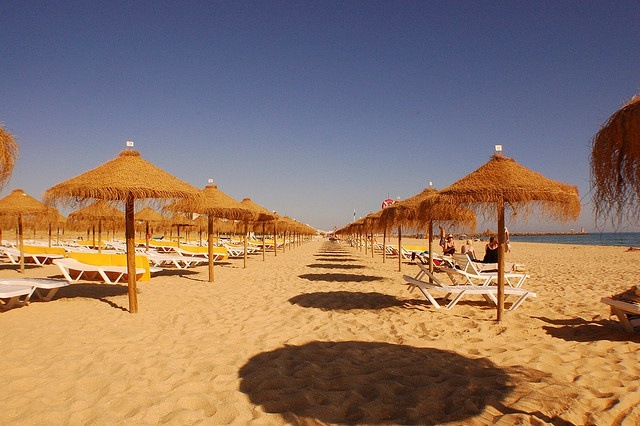Describe the objects in this image and their specific colors. I can see umbrella in darkblue, red, maroon, and gray tones, umbrella in darkblue, orange, and red tones, umbrella in darkblue, brown, maroon, and gray tones, chair in darkblue, tan, and beige tones, and bench in darkblue, tan, maroon, and beige tones in this image. 